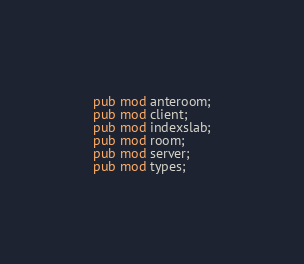Convert code to text. <code><loc_0><loc_0><loc_500><loc_500><_Rust_>pub mod anteroom;
pub mod client;
pub mod indexslab;
pub mod room;
pub mod server;
pub mod types;
</code> 